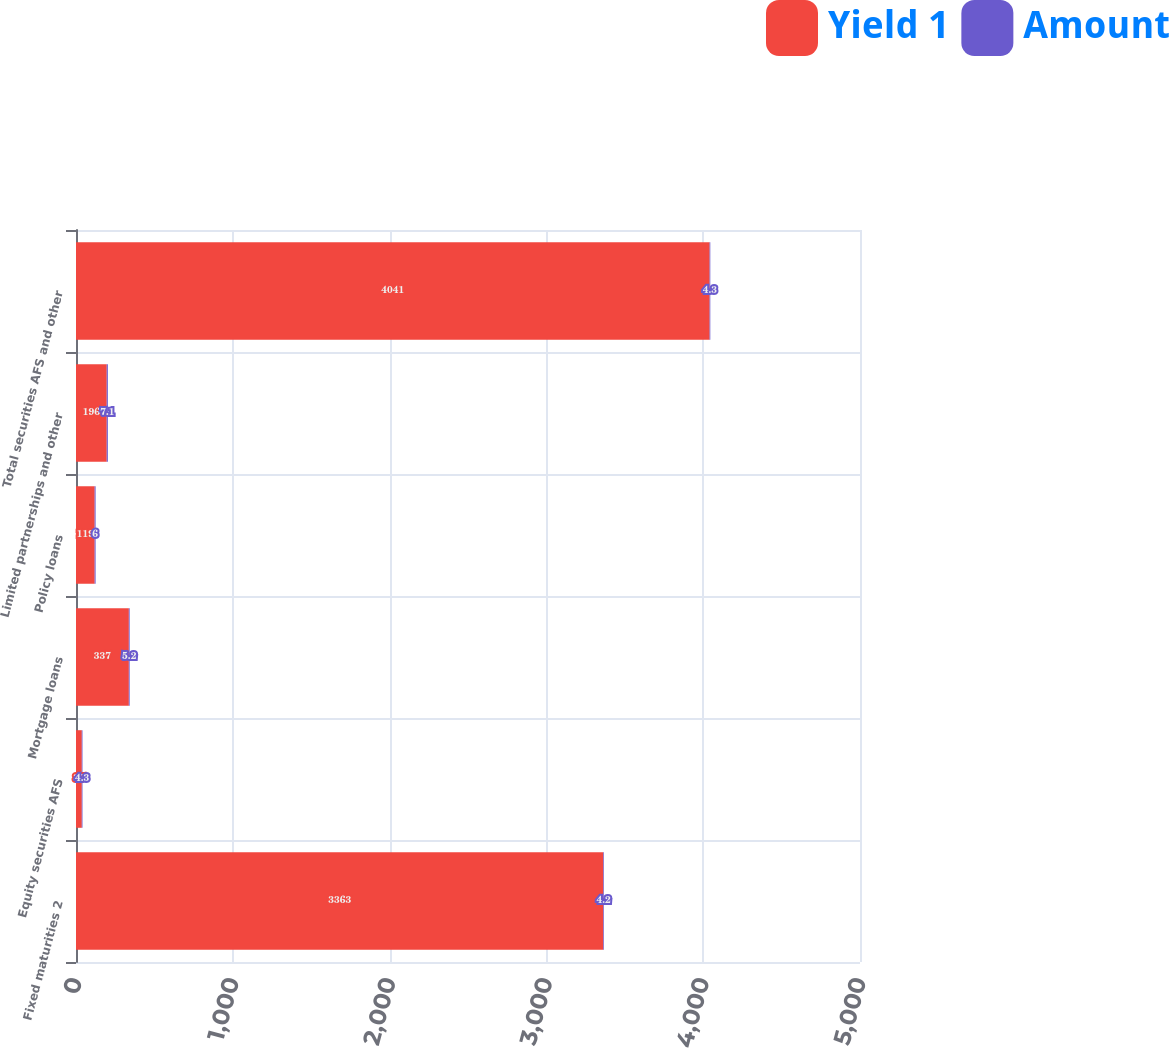<chart> <loc_0><loc_0><loc_500><loc_500><stacked_bar_chart><ecel><fcel>Fixed maturities 2<fcel>Equity securities AFS<fcel>Mortgage loans<fcel>Policy loans<fcel>Limited partnerships and other<fcel>Total securities AFS and other<nl><fcel>Yield 1<fcel>3363<fcel>37<fcel>337<fcel>119<fcel>196<fcel>4041<nl><fcel>Amount<fcel>4.2<fcel>4.3<fcel>5.2<fcel>6<fcel>7.1<fcel>4.3<nl></chart> 